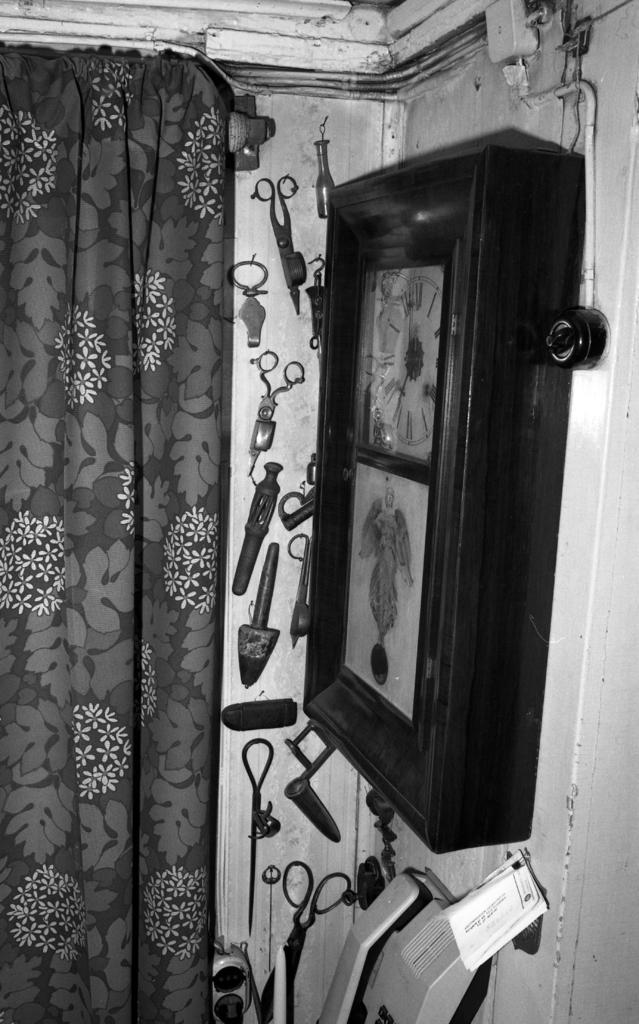What type of object is hanging on the wall in the image? There is a wall clock in the image. What tool can be seen in the image? There are scissors in the image. What material are some of the objects made of in the image? There are metal instruments in the image. What type of window treatment is present in the image? There is a curtain in the image. How many boys are visible in the image? There are no boys present in the image. What is the name of the downtown area mentioned in the image? There is no mention of a downtown area or any specific location in the image. 